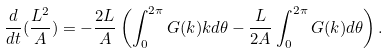Convert formula to latex. <formula><loc_0><loc_0><loc_500><loc_500>\frac { d } { d t } ( \frac { L ^ { 2 } } { A } ) = - \frac { 2 L } { A } \left ( \int ^ { 2 \pi } _ { 0 } G ( k ) k d \theta - \frac { L } { 2 A } \int ^ { 2 \pi } _ { 0 } G ( k ) d \theta \right ) .</formula> 